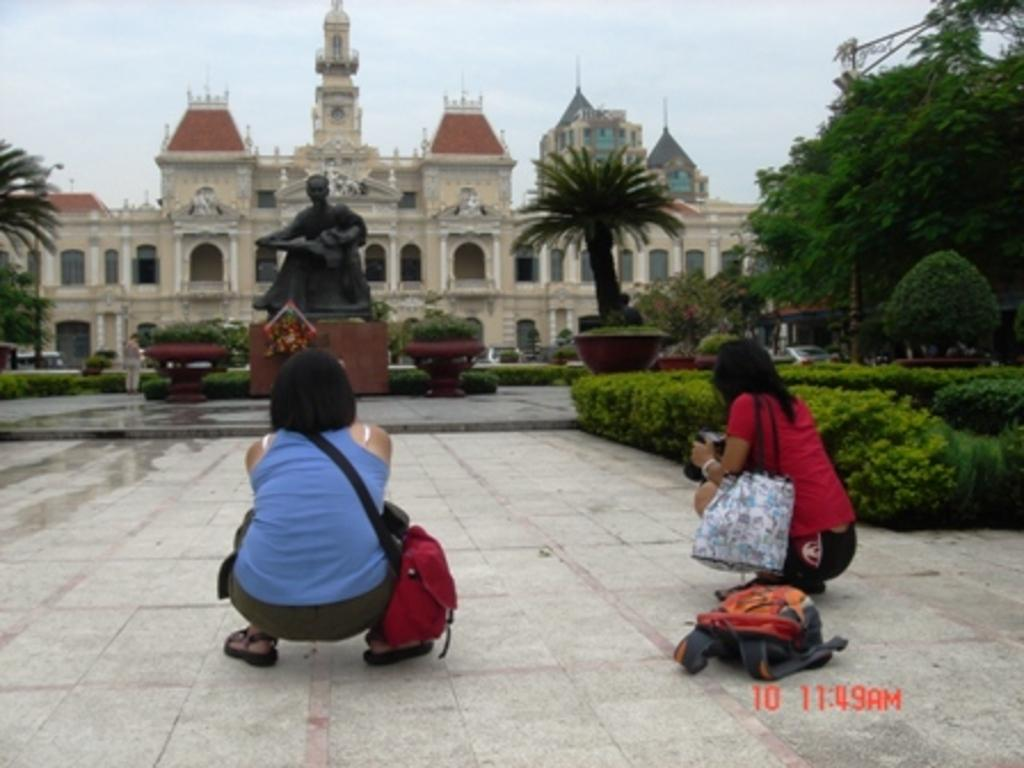How many persons are sitting in the middle of the image? There are two persons sitting in the middle of the image. What is in front of the sitting persons? There are plants, trees, a statue, and a building in front of the sitting persons. What can be seen in the sky at the top of the image? There are clouds visible in the sky at the top of the image. Can you hear the song being sung by the goldfish in the image? There are no goldfish or songs present in the image. 